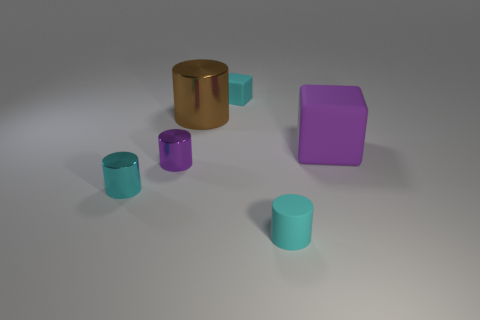How many other things are there of the same material as the cyan cube? Including the cyan cube itself, there are three items in the image that appear to be made of a similar matte material. If we look closely, besides the cyan cube, there are two smaller cyan cylinders that seem to share the same material characteristics. 